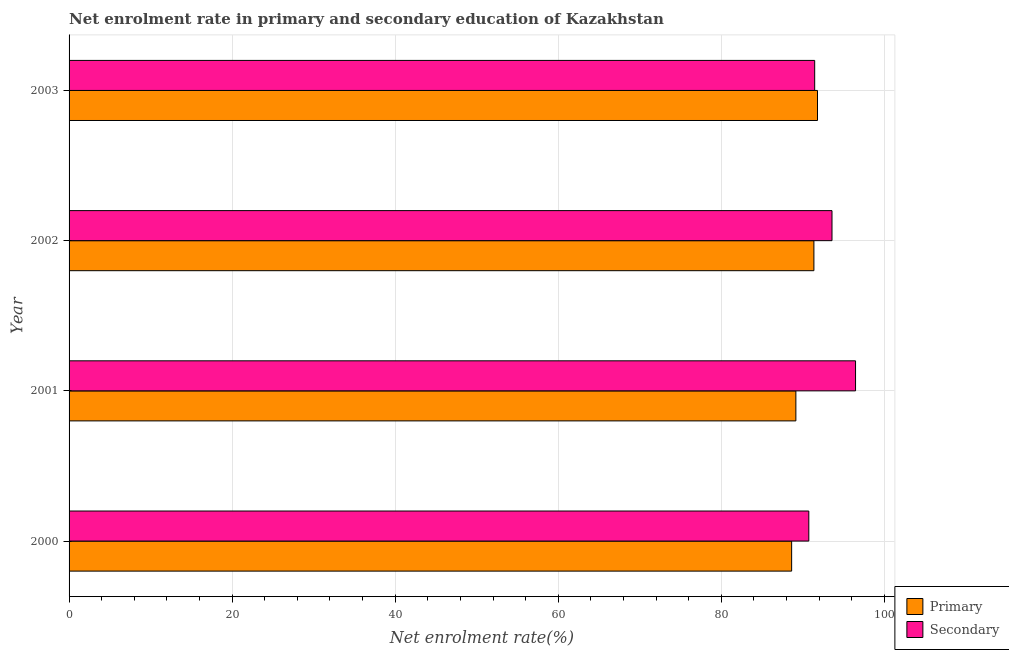Are the number of bars on each tick of the Y-axis equal?
Ensure brevity in your answer.  Yes. How many bars are there on the 2nd tick from the top?
Provide a short and direct response. 2. How many bars are there on the 1st tick from the bottom?
Provide a short and direct response. 2. What is the label of the 2nd group of bars from the top?
Your answer should be very brief. 2002. In how many cases, is the number of bars for a given year not equal to the number of legend labels?
Your response must be concise. 0. What is the enrollment rate in primary education in 2000?
Offer a terse response. 88.63. Across all years, what is the maximum enrollment rate in primary education?
Ensure brevity in your answer.  91.81. Across all years, what is the minimum enrollment rate in secondary education?
Your answer should be compact. 90.74. In which year was the enrollment rate in secondary education minimum?
Ensure brevity in your answer.  2000. What is the total enrollment rate in secondary education in the graph?
Your response must be concise. 372.25. What is the difference between the enrollment rate in secondary education in 2000 and that in 2001?
Your response must be concise. -5.73. What is the difference between the enrollment rate in primary education in 2003 and the enrollment rate in secondary education in 2002?
Provide a short and direct response. -1.78. What is the average enrollment rate in primary education per year?
Make the answer very short. 90.24. In the year 2000, what is the difference between the enrollment rate in secondary education and enrollment rate in primary education?
Offer a very short reply. 2.11. In how many years, is the enrollment rate in secondary education greater than 76 %?
Make the answer very short. 4. What is the ratio of the enrollment rate in secondary education in 2000 to that in 2001?
Your answer should be very brief. 0.94. Is the enrollment rate in secondary education in 2000 less than that in 2003?
Ensure brevity in your answer.  Yes. What is the difference between the highest and the second highest enrollment rate in secondary education?
Your response must be concise. 2.89. What is the difference between the highest and the lowest enrollment rate in primary education?
Your response must be concise. 3.17. Is the sum of the enrollment rate in secondary education in 2001 and 2002 greater than the maximum enrollment rate in primary education across all years?
Ensure brevity in your answer.  Yes. What does the 1st bar from the top in 2000 represents?
Your answer should be compact. Secondary. What does the 1st bar from the bottom in 2000 represents?
Give a very brief answer. Primary. How many bars are there?
Your answer should be very brief. 8. Are all the bars in the graph horizontal?
Provide a succinct answer. Yes. What is the difference between two consecutive major ticks on the X-axis?
Give a very brief answer. 20. Does the graph contain any zero values?
Provide a short and direct response. No. How many legend labels are there?
Give a very brief answer. 2. What is the title of the graph?
Provide a short and direct response. Net enrolment rate in primary and secondary education of Kazakhstan. What is the label or title of the X-axis?
Your answer should be very brief. Net enrolment rate(%). What is the Net enrolment rate(%) of Primary in 2000?
Make the answer very short. 88.63. What is the Net enrolment rate(%) of Secondary in 2000?
Your response must be concise. 90.74. What is the Net enrolment rate(%) of Primary in 2001?
Ensure brevity in your answer.  89.15. What is the Net enrolment rate(%) in Secondary in 2001?
Give a very brief answer. 96.47. What is the Net enrolment rate(%) of Primary in 2002?
Offer a very short reply. 91.36. What is the Net enrolment rate(%) of Secondary in 2002?
Make the answer very short. 93.58. What is the Net enrolment rate(%) of Primary in 2003?
Give a very brief answer. 91.81. What is the Net enrolment rate(%) of Secondary in 2003?
Give a very brief answer. 91.46. Across all years, what is the maximum Net enrolment rate(%) in Primary?
Your response must be concise. 91.81. Across all years, what is the maximum Net enrolment rate(%) in Secondary?
Your answer should be compact. 96.47. Across all years, what is the minimum Net enrolment rate(%) in Primary?
Make the answer very short. 88.63. Across all years, what is the minimum Net enrolment rate(%) in Secondary?
Offer a very short reply. 90.74. What is the total Net enrolment rate(%) in Primary in the graph?
Offer a very short reply. 360.95. What is the total Net enrolment rate(%) of Secondary in the graph?
Offer a very short reply. 372.25. What is the difference between the Net enrolment rate(%) in Primary in 2000 and that in 2001?
Your response must be concise. -0.52. What is the difference between the Net enrolment rate(%) in Secondary in 2000 and that in 2001?
Offer a terse response. -5.73. What is the difference between the Net enrolment rate(%) of Primary in 2000 and that in 2002?
Your answer should be very brief. -2.73. What is the difference between the Net enrolment rate(%) of Secondary in 2000 and that in 2002?
Provide a succinct answer. -2.84. What is the difference between the Net enrolment rate(%) in Primary in 2000 and that in 2003?
Keep it short and to the point. -3.17. What is the difference between the Net enrolment rate(%) of Secondary in 2000 and that in 2003?
Your response must be concise. -0.72. What is the difference between the Net enrolment rate(%) in Primary in 2001 and that in 2002?
Give a very brief answer. -2.21. What is the difference between the Net enrolment rate(%) of Secondary in 2001 and that in 2002?
Provide a succinct answer. 2.89. What is the difference between the Net enrolment rate(%) in Primary in 2001 and that in 2003?
Your answer should be very brief. -2.65. What is the difference between the Net enrolment rate(%) in Secondary in 2001 and that in 2003?
Ensure brevity in your answer.  5.01. What is the difference between the Net enrolment rate(%) of Primary in 2002 and that in 2003?
Provide a short and direct response. -0.44. What is the difference between the Net enrolment rate(%) in Secondary in 2002 and that in 2003?
Your answer should be compact. 2.12. What is the difference between the Net enrolment rate(%) of Primary in 2000 and the Net enrolment rate(%) of Secondary in 2001?
Make the answer very short. -7.84. What is the difference between the Net enrolment rate(%) in Primary in 2000 and the Net enrolment rate(%) in Secondary in 2002?
Your answer should be very brief. -4.95. What is the difference between the Net enrolment rate(%) of Primary in 2000 and the Net enrolment rate(%) of Secondary in 2003?
Provide a succinct answer. -2.83. What is the difference between the Net enrolment rate(%) in Primary in 2001 and the Net enrolment rate(%) in Secondary in 2002?
Your answer should be compact. -4.43. What is the difference between the Net enrolment rate(%) in Primary in 2001 and the Net enrolment rate(%) in Secondary in 2003?
Your response must be concise. -2.31. What is the difference between the Net enrolment rate(%) of Primary in 2002 and the Net enrolment rate(%) of Secondary in 2003?
Offer a very short reply. -0.09. What is the average Net enrolment rate(%) in Primary per year?
Provide a short and direct response. 90.24. What is the average Net enrolment rate(%) in Secondary per year?
Your answer should be compact. 93.06. In the year 2000, what is the difference between the Net enrolment rate(%) of Primary and Net enrolment rate(%) of Secondary?
Ensure brevity in your answer.  -2.11. In the year 2001, what is the difference between the Net enrolment rate(%) of Primary and Net enrolment rate(%) of Secondary?
Provide a succinct answer. -7.32. In the year 2002, what is the difference between the Net enrolment rate(%) in Primary and Net enrolment rate(%) in Secondary?
Give a very brief answer. -2.22. In the year 2003, what is the difference between the Net enrolment rate(%) in Primary and Net enrolment rate(%) in Secondary?
Your answer should be compact. 0.35. What is the ratio of the Net enrolment rate(%) in Primary in 2000 to that in 2001?
Your response must be concise. 0.99. What is the ratio of the Net enrolment rate(%) of Secondary in 2000 to that in 2001?
Keep it short and to the point. 0.94. What is the ratio of the Net enrolment rate(%) in Primary in 2000 to that in 2002?
Your answer should be very brief. 0.97. What is the ratio of the Net enrolment rate(%) in Secondary in 2000 to that in 2002?
Provide a succinct answer. 0.97. What is the ratio of the Net enrolment rate(%) in Primary in 2000 to that in 2003?
Ensure brevity in your answer.  0.97. What is the ratio of the Net enrolment rate(%) in Secondary in 2000 to that in 2003?
Keep it short and to the point. 0.99. What is the ratio of the Net enrolment rate(%) in Primary in 2001 to that in 2002?
Give a very brief answer. 0.98. What is the ratio of the Net enrolment rate(%) of Secondary in 2001 to that in 2002?
Your answer should be very brief. 1.03. What is the ratio of the Net enrolment rate(%) of Primary in 2001 to that in 2003?
Keep it short and to the point. 0.97. What is the ratio of the Net enrolment rate(%) of Secondary in 2001 to that in 2003?
Give a very brief answer. 1.05. What is the ratio of the Net enrolment rate(%) of Primary in 2002 to that in 2003?
Offer a terse response. 1. What is the ratio of the Net enrolment rate(%) of Secondary in 2002 to that in 2003?
Your response must be concise. 1.02. What is the difference between the highest and the second highest Net enrolment rate(%) in Primary?
Offer a terse response. 0.44. What is the difference between the highest and the second highest Net enrolment rate(%) in Secondary?
Make the answer very short. 2.89. What is the difference between the highest and the lowest Net enrolment rate(%) in Primary?
Your answer should be very brief. 3.17. What is the difference between the highest and the lowest Net enrolment rate(%) of Secondary?
Offer a very short reply. 5.73. 